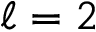<formula> <loc_0><loc_0><loc_500><loc_500>\ell = 2</formula> 